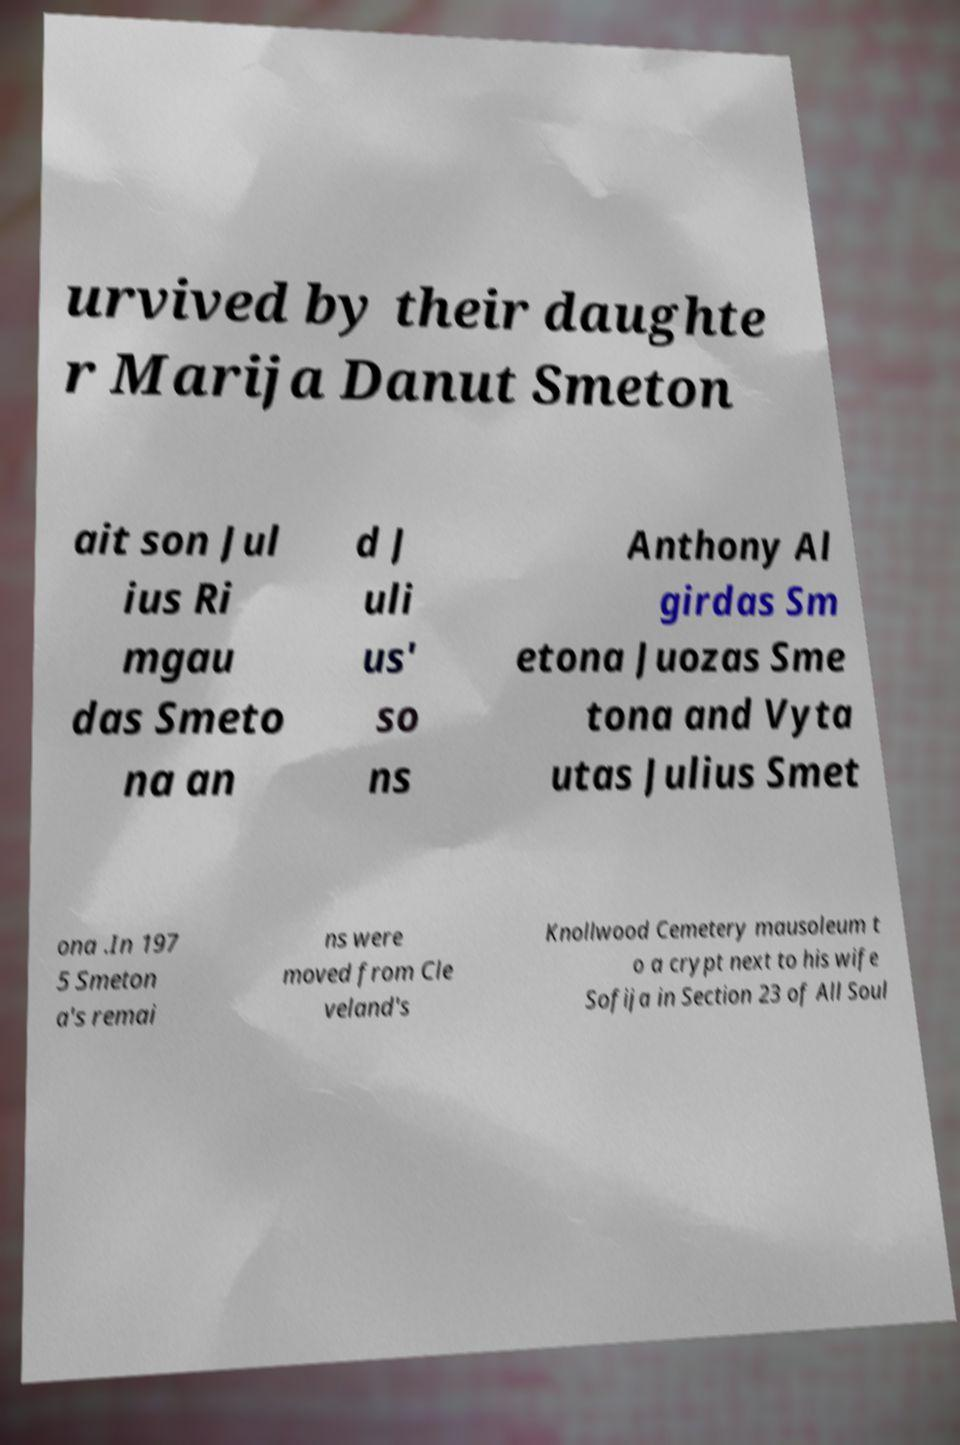Please identify and transcribe the text found in this image. urvived by their daughte r Marija Danut Smeton ait son Jul ius Ri mgau das Smeto na an d J uli us' so ns Anthony Al girdas Sm etona Juozas Sme tona and Vyta utas Julius Smet ona .In 197 5 Smeton a's remai ns were moved from Cle veland's Knollwood Cemetery mausoleum t o a crypt next to his wife Sofija in Section 23 of All Soul 